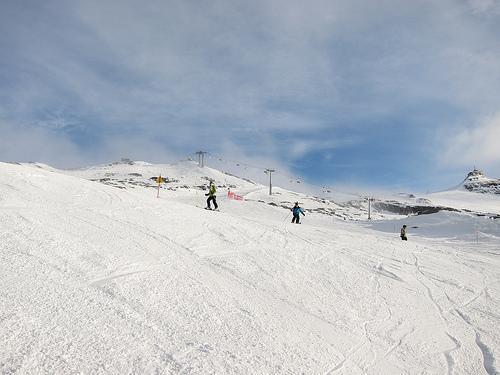How many skiers are shown?
Give a very brief answer. 3. 